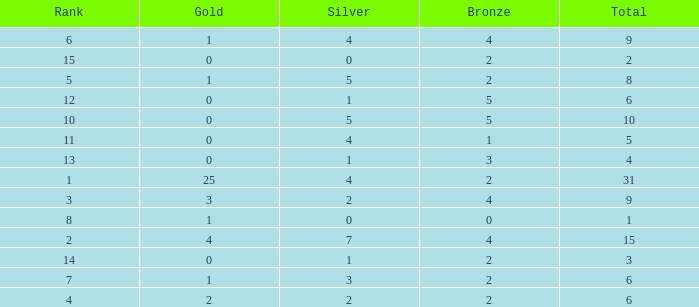What is the highest rank of the medal total less than 15, more than 2 bronzes, 0 gold and 1 silver? 13.0. 